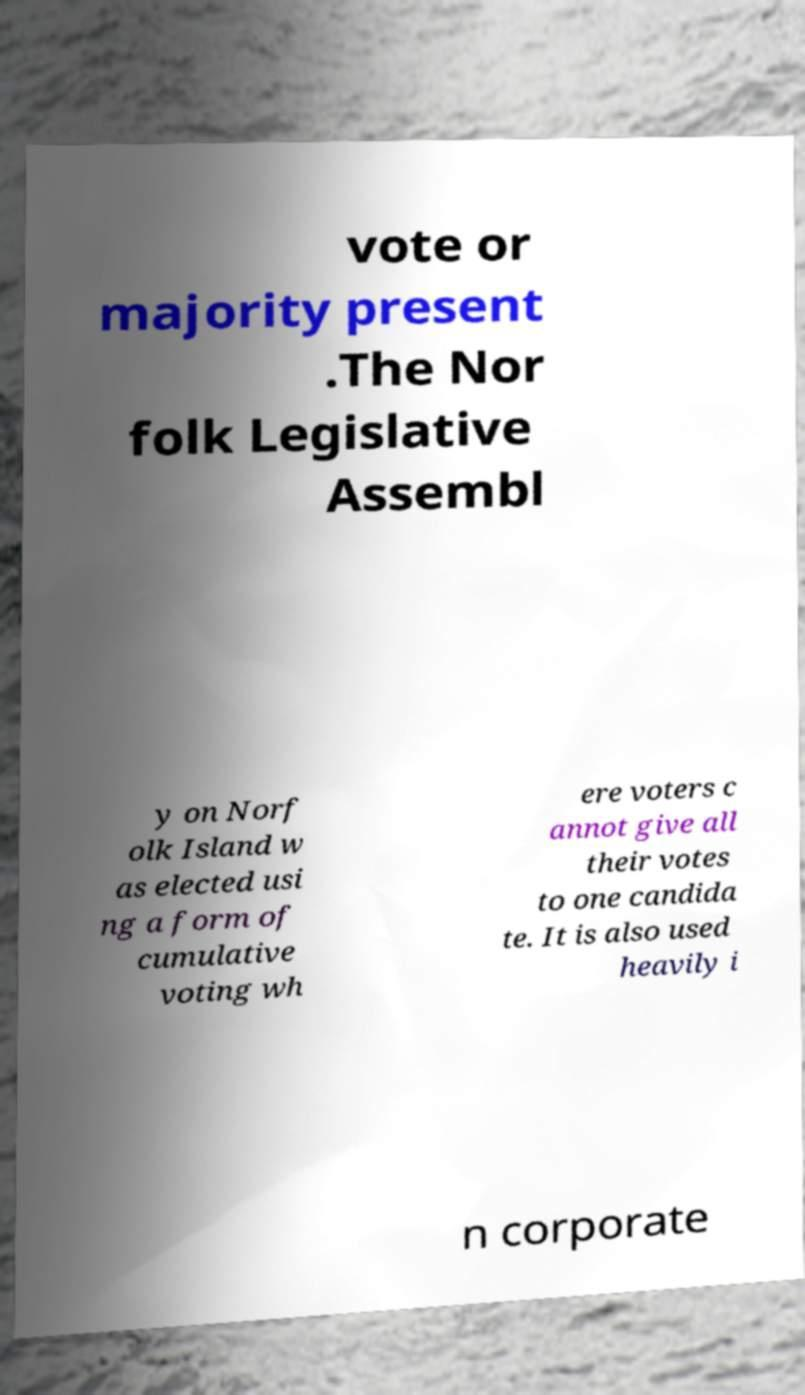For documentation purposes, I need the text within this image transcribed. Could you provide that? vote or majority present .The Nor folk Legislative Assembl y on Norf olk Island w as elected usi ng a form of cumulative voting wh ere voters c annot give all their votes to one candida te. It is also used heavily i n corporate 